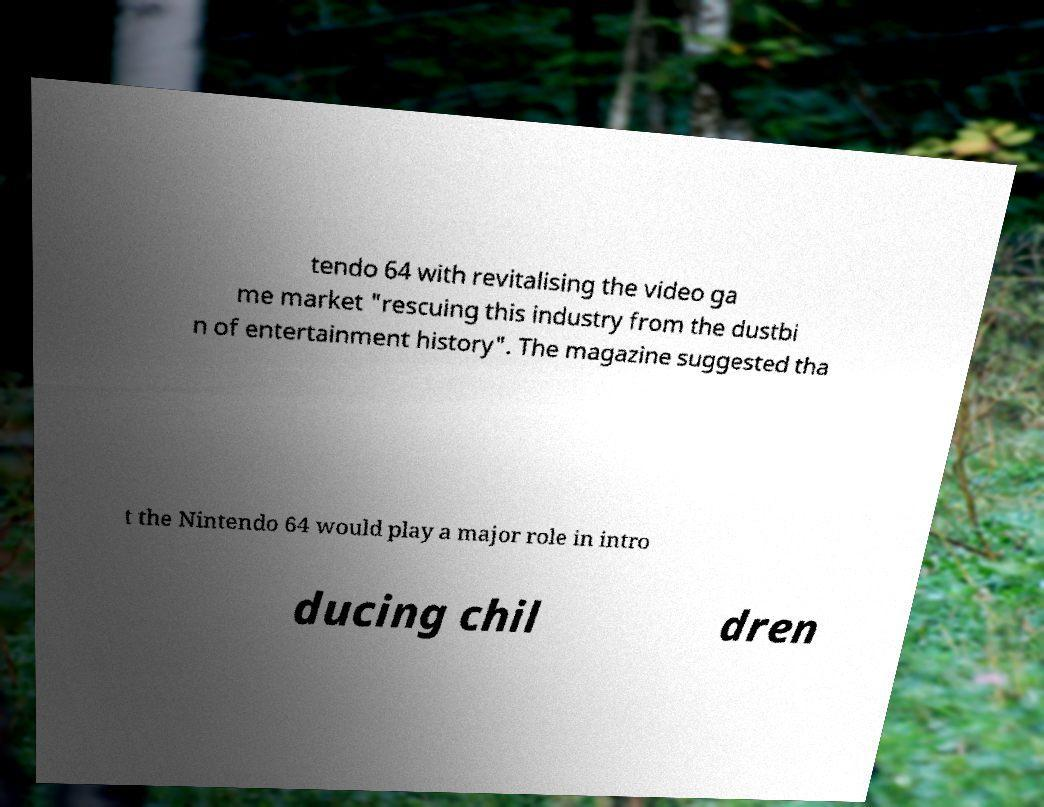There's text embedded in this image that I need extracted. Can you transcribe it verbatim? tendo 64 with revitalising the video ga me market "rescuing this industry from the dustbi n of entertainment history". The magazine suggested tha t the Nintendo 64 would play a major role in intro ducing chil dren 